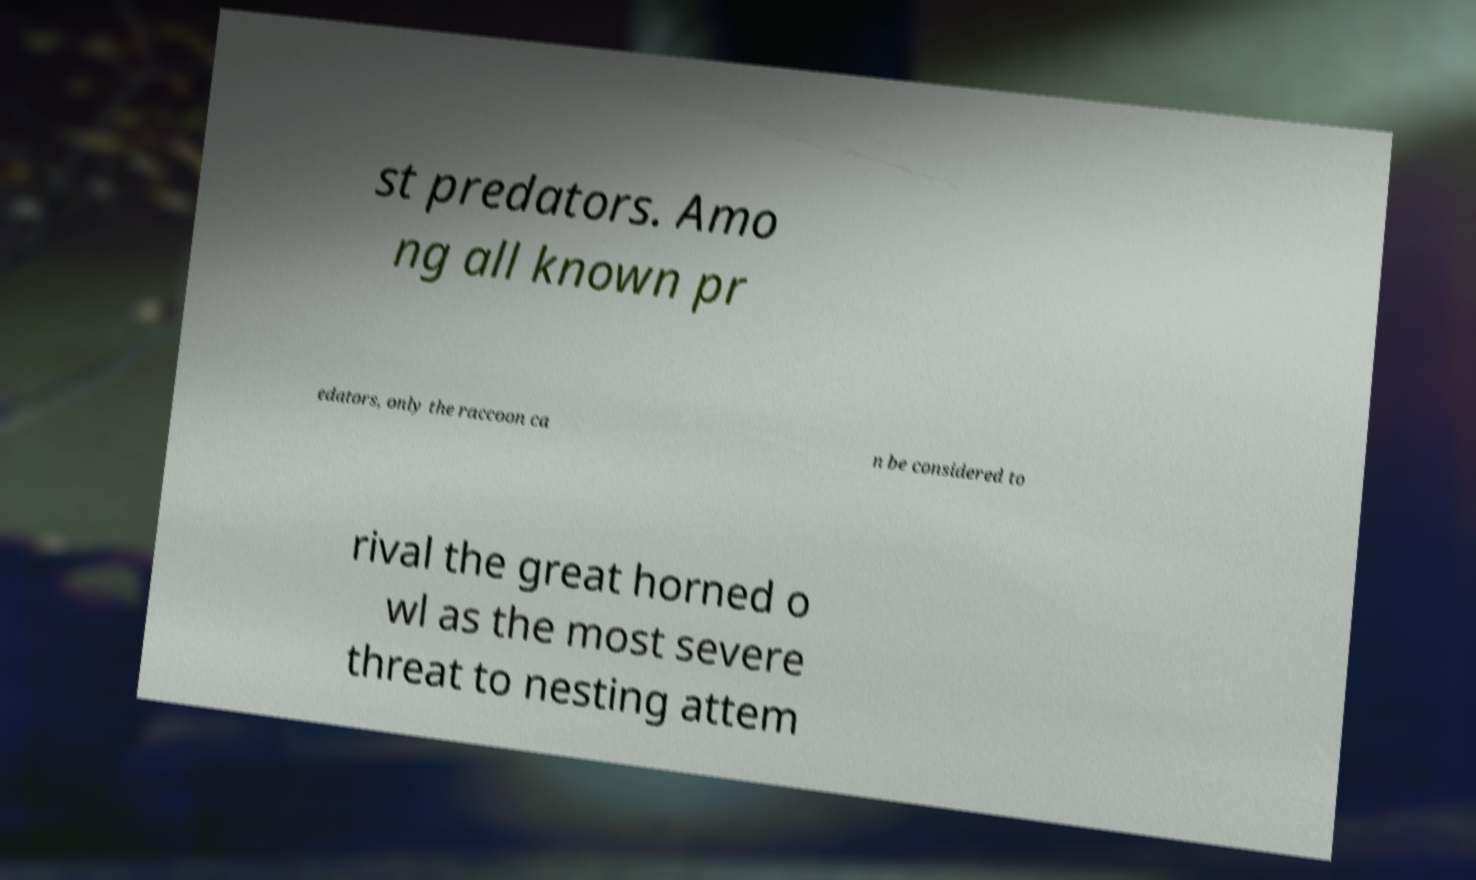I need the written content from this picture converted into text. Can you do that? st predators. Amo ng all known pr edators, only the raccoon ca n be considered to rival the great horned o wl as the most severe threat to nesting attem 